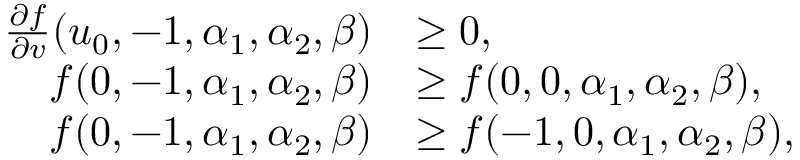<formula> <loc_0><loc_0><loc_500><loc_500>\begin{array} { r l } { \frac { \partial f } { \partial v } ( u _ { 0 } , - 1 , \alpha _ { 1 } , \alpha _ { 2 } , \beta ) } & { \geq 0 , } \\ { f ( 0 , - 1 , \alpha _ { 1 } , \alpha _ { 2 } , \beta ) } & { \geq f ( 0 , 0 , \alpha _ { 1 } , \alpha _ { 2 } , \beta ) , } \\ { f ( 0 , - 1 , \alpha _ { 1 } , \alpha _ { 2 } , \beta ) } & { \geq f ( - 1 , 0 , \alpha _ { 1 } , \alpha _ { 2 } , \beta ) , } \end{array}</formula> 